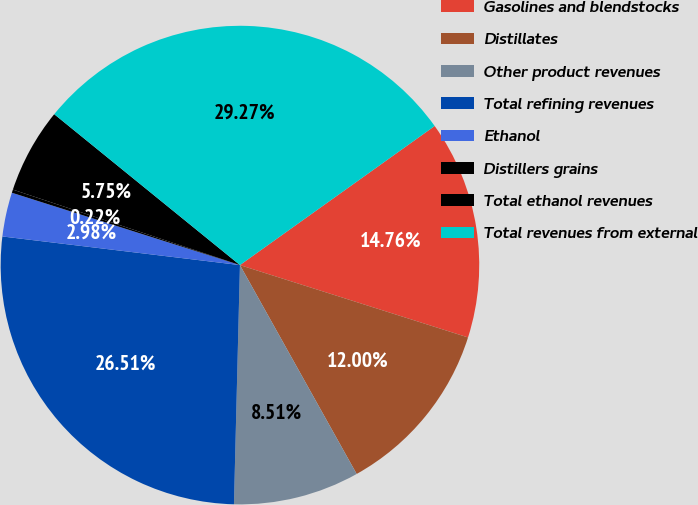<chart> <loc_0><loc_0><loc_500><loc_500><pie_chart><fcel>Gasolines and blendstocks<fcel>Distillates<fcel>Other product revenues<fcel>Total refining revenues<fcel>Ethanol<fcel>Distillers grains<fcel>Total ethanol revenues<fcel>Total revenues from external<nl><fcel>14.76%<fcel>12.0%<fcel>8.51%<fcel>26.51%<fcel>2.98%<fcel>0.22%<fcel>5.75%<fcel>29.27%<nl></chart> 